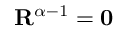Convert formula to latex. <formula><loc_0><loc_0><loc_500><loc_500>R ^ { \alpha - 1 } = 0</formula> 